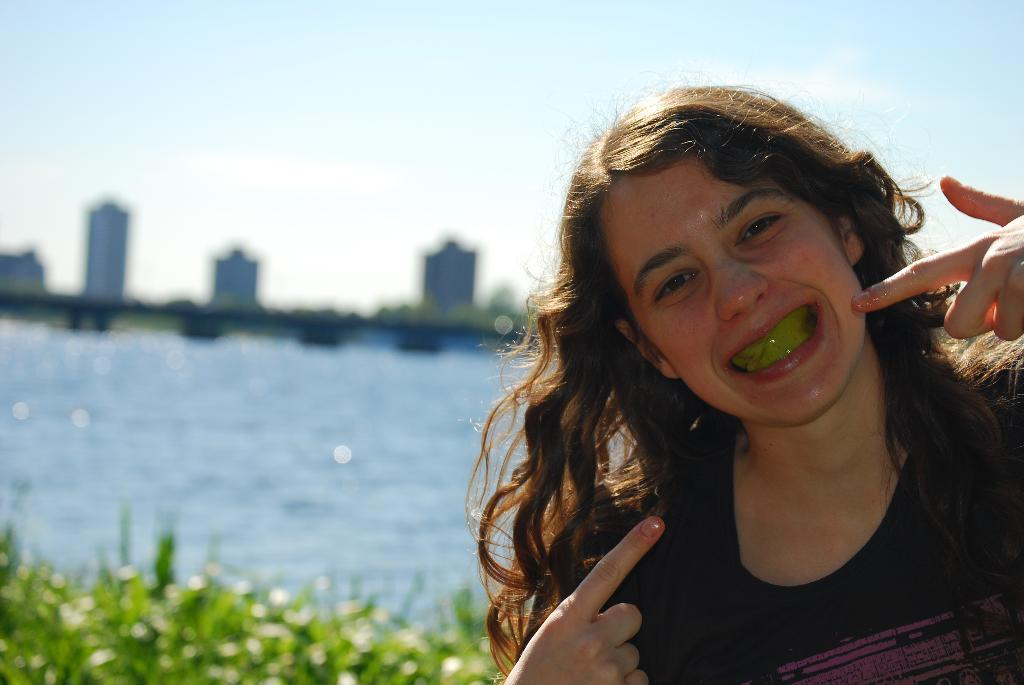Who is present in the image? There is a woman in the image. What type of vegetation can be seen in the image? There are leaves in the image. What natural element is visible in the image? There is water visible in the image. What can be seen in the background of the image? There are buildings and the sky visible in the background of the image. What type of corn is being harvested in the image? There is no corn present in the image. What answer is the woman providing in the image? The image does not show the woman providing an answer to any question or statement. 